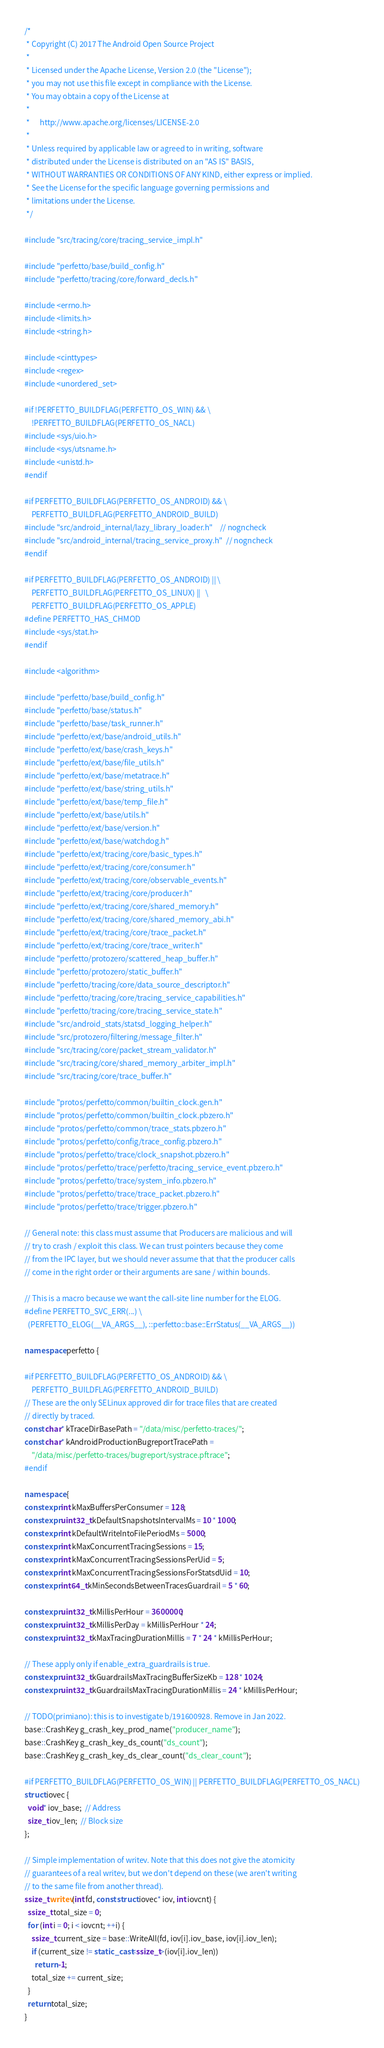Convert code to text. <code><loc_0><loc_0><loc_500><loc_500><_C++_>/*
 * Copyright (C) 2017 The Android Open Source Project
 *
 * Licensed under the Apache License, Version 2.0 (the "License");
 * you may not use this file except in compliance with the License.
 * You may obtain a copy of the License at
 *
 *      http://www.apache.org/licenses/LICENSE-2.0
 *
 * Unless required by applicable law or agreed to in writing, software
 * distributed under the License is distributed on an "AS IS" BASIS,
 * WITHOUT WARRANTIES OR CONDITIONS OF ANY KIND, either express or implied.
 * See the License for the specific language governing permissions and
 * limitations under the License.
 */

#include "src/tracing/core/tracing_service_impl.h"

#include "perfetto/base/build_config.h"
#include "perfetto/tracing/core/forward_decls.h"

#include <errno.h>
#include <limits.h>
#include <string.h>

#include <cinttypes>
#include <regex>
#include <unordered_set>

#if !PERFETTO_BUILDFLAG(PERFETTO_OS_WIN) && \
    !PERFETTO_BUILDFLAG(PERFETTO_OS_NACL)
#include <sys/uio.h>
#include <sys/utsname.h>
#include <unistd.h>
#endif

#if PERFETTO_BUILDFLAG(PERFETTO_OS_ANDROID) && \
    PERFETTO_BUILDFLAG(PERFETTO_ANDROID_BUILD)
#include "src/android_internal/lazy_library_loader.h"    // nogncheck
#include "src/android_internal/tracing_service_proxy.h"  // nogncheck
#endif

#if PERFETTO_BUILDFLAG(PERFETTO_OS_ANDROID) || \
    PERFETTO_BUILDFLAG(PERFETTO_OS_LINUX) ||   \
    PERFETTO_BUILDFLAG(PERFETTO_OS_APPLE)
#define PERFETTO_HAS_CHMOD
#include <sys/stat.h>
#endif

#include <algorithm>

#include "perfetto/base/build_config.h"
#include "perfetto/base/status.h"
#include "perfetto/base/task_runner.h"
#include "perfetto/ext/base/android_utils.h"
#include "perfetto/ext/base/crash_keys.h"
#include "perfetto/ext/base/file_utils.h"
#include "perfetto/ext/base/metatrace.h"
#include "perfetto/ext/base/string_utils.h"
#include "perfetto/ext/base/temp_file.h"
#include "perfetto/ext/base/utils.h"
#include "perfetto/ext/base/version.h"
#include "perfetto/ext/base/watchdog.h"
#include "perfetto/ext/tracing/core/basic_types.h"
#include "perfetto/ext/tracing/core/consumer.h"
#include "perfetto/ext/tracing/core/observable_events.h"
#include "perfetto/ext/tracing/core/producer.h"
#include "perfetto/ext/tracing/core/shared_memory.h"
#include "perfetto/ext/tracing/core/shared_memory_abi.h"
#include "perfetto/ext/tracing/core/trace_packet.h"
#include "perfetto/ext/tracing/core/trace_writer.h"
#include "perfetto/protozero/scattered_heap_buffer.h"
#include "perfetto/protozero/static_buffer.h"
#include "perfetto/tracing/core/data_source_descriptor.h"
#include "perfetto/tracing/core/tracing_service_capabilities.h"
#include "perfetto/tracing/core/tracing_service_state.h"
#include "src/android_stats/statsd_logging_helper.h"
#include "src/protozero/filtering/message_filter.h"
#include "src/tracing/core/packet_stream_validator.h"
#include "src/tracing/core/shared_memory_arbiter_impl.h"
#include "src/tracing/core/trace_buffer.h"

#include "protos/perfetto/common/builtin_clock.gen.h"
#include "protos/perfetto/common/builtin_clock.pbzero.h"
#include "protos/perfetto/common/trace_stats.pbzero.h"
#include "protos/perfetto/config/trace_config.pbzero.h"
#include "protos/perfetto/trace/clock_snapshot.pbzero.h"
#include "protos/perfetto/trace/perfetto/tracing_service_event.pbzero.h"
#include "protos/perfetto/trace/system_info.pbzero.h"
#include "protos/perfetto/trace/trace_packet.pbzero.h"
#include "protos/perfetto/trace/trigger.pbzero.h"

// General note: this class must assume that Producers are malicious and will
// try to crash / exploit this class. We can trust pointers because they come
// from the IPC layer, but we should never assume that that the producer calls
// come in the right order or their arguments are sane / within bounds.

// This is a macro because we want the call-site line number for the ELOG.
#define PERFETTO_SVC_ERR(...) \
  (PERFETTO_ELOG(__VA_ARGS__), ::perfetto::base::ErrStatus(__VA_ARGS__))

namespace perfetto {

#if PERFETTO_BUILDFLAG(PERFETTO_OS_ANDROID) && \
    PERFETTO_BUILDFLAG(PERFETTO_ANDROID_BUILD)
// These are the only SELinux approved dir for trace files that are created
// directly by traced.
const char* kTraceDirBasePath = "/data/misc/perfetto-traces/";
const char* kAndroidProductionBugreportTracePath =
    "/data/misc/perfetto-traces/bugreport/systrace.pftrace";
#endif

namespace {
constexpr int kMaxBuffersPerConsumer = 128;
constexpr uint32_t kDefaultSnapshotsIntervalMs = 10 * 1000;
constexpr int kDefaultWriteIntoFilePeriodMs = 5000;
constexpr int kMaxConcurrentTracingSessions = 15;
constexpr int kMaxConcurrentTracingSessionsPerUid = 5;
constexpr int kMaxConcurrentTracingSessionsForStatsdUid = 10;
constexpr int64_t kMinSecondsBetweenTracesGuardrail = 5 * 60;

constexpr uint32_t kMillisPerHour = 3600000;
constexpr uint32_t kMillisPerDay = kMillisPerHour * 24;
constexpr uint32_t kMaxTracingDurationMillis = 7 * 24 * kMillisPerHour;

// These apply only if enable_extra_guardrails is true.
constexpr uint32_t kGuardrailsMaxTracingBufferSizeKb = 128 * 1024;
constexpr uint32_t kGuardrailsMaxTracingDurationMillis = 24 * kMillisPerHour;

// TODO(primiano): this is to investigate b/191600928. Remove in Jan 2022.
base::CrashKey g_crash_key_prod_name("producer_name");
base::CrashKey g_crash_key_ds_count("ds_count");
base::CrashKey g_crash_key_ds_clear_count("ds_clear_count");

#if PERFETTO_BUILDFLAG(PERFETTO_OS_WIN) || PERFETTO_BUILDFLAG(PERFETTO_OS_NACL)
struct iovec {
  void* iov_base;  // Address
  size_t iov_len;  // Block size
};

// Simple implementation of writev. Note that this does not give the atomicity
// guarantees of a real writev, but we don't depend on these (we aren't writing
// to the same file from another thread).
ssize_t writev(int fd, const struct iovec* iov, int iovcnt) {
  ssize_t total_size = 0;
  for (int i = 0; i < iovcnt; ++i) {
    ssize_t current_size = base::WriteAll(fd, iov[i].iov_base, iov[i].iov_len);
    if (current_size != static_cast<ssize_t>(iov[i].iov_len))
      return -1;
    total_size += current_size;
  }
  return total_size;
}
</code> 